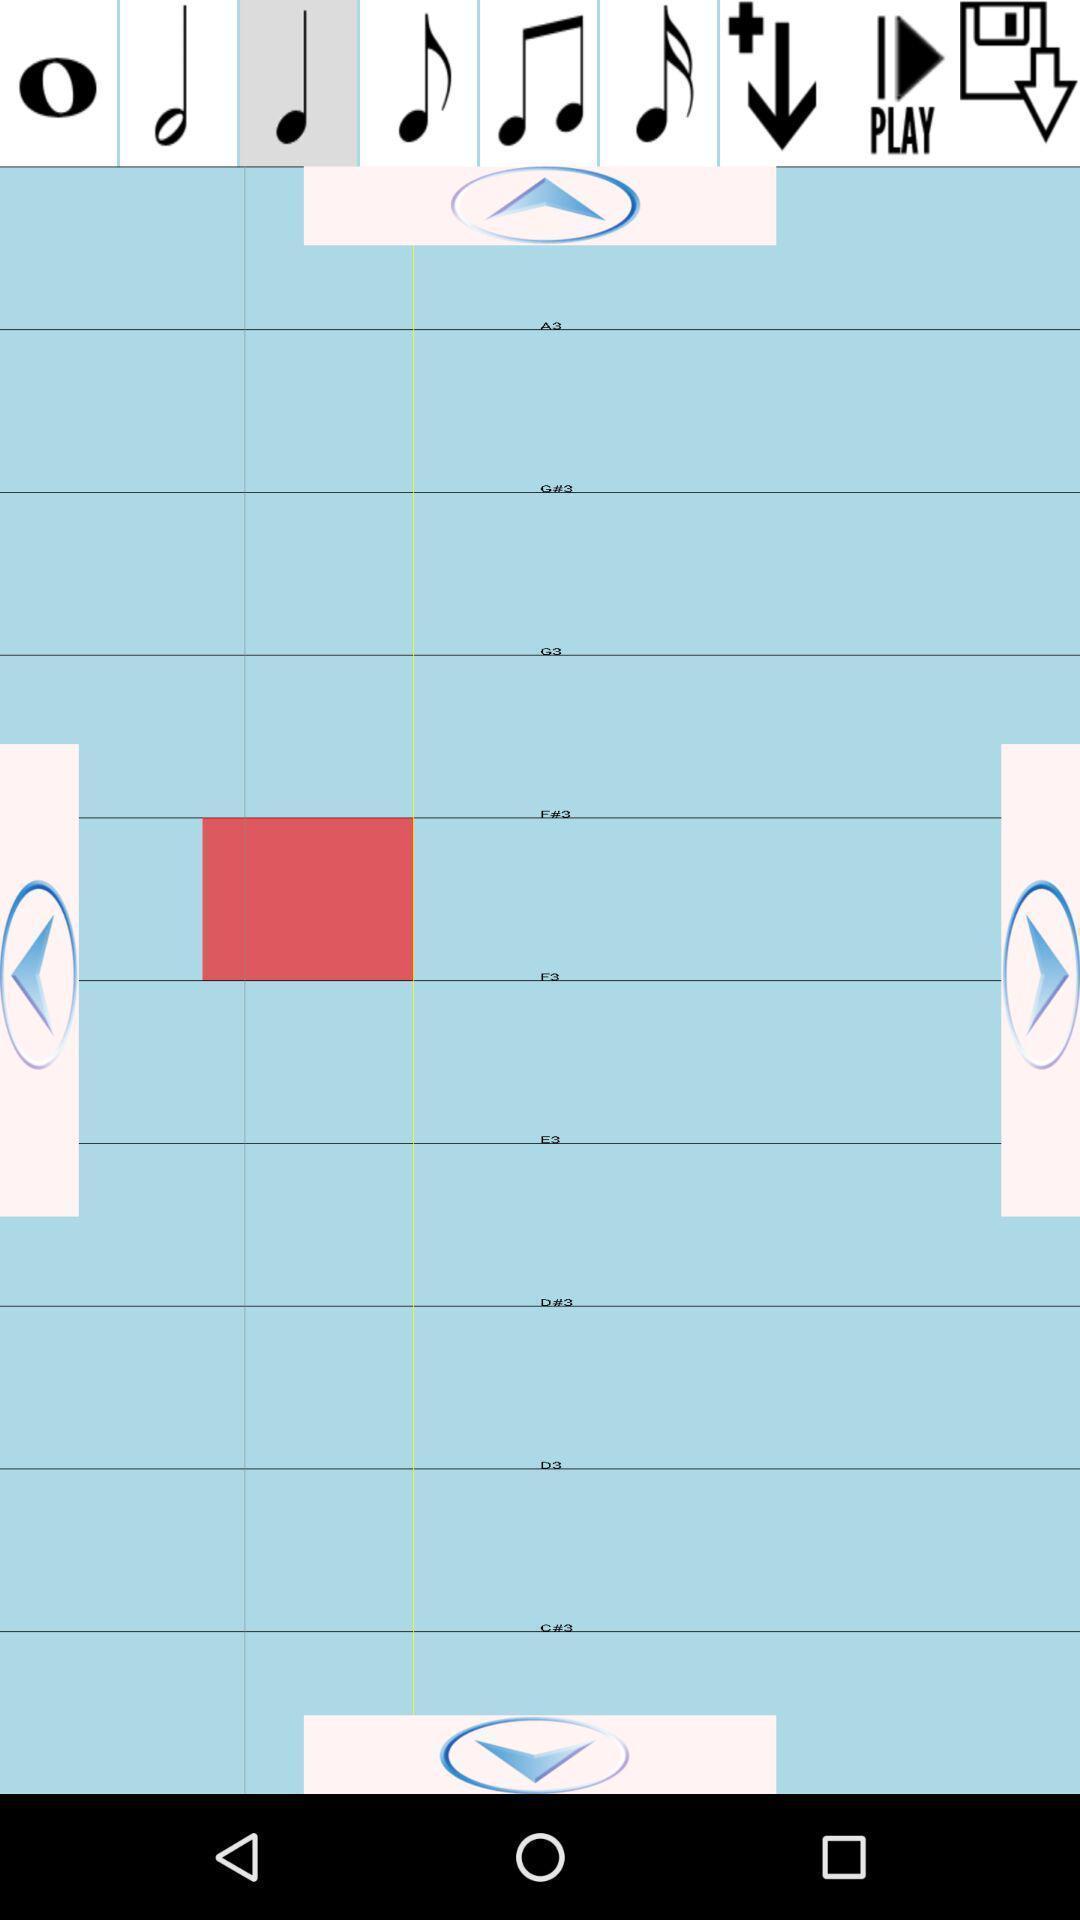Provide a textual representation of this image. Page with different clefs in music learning app. 